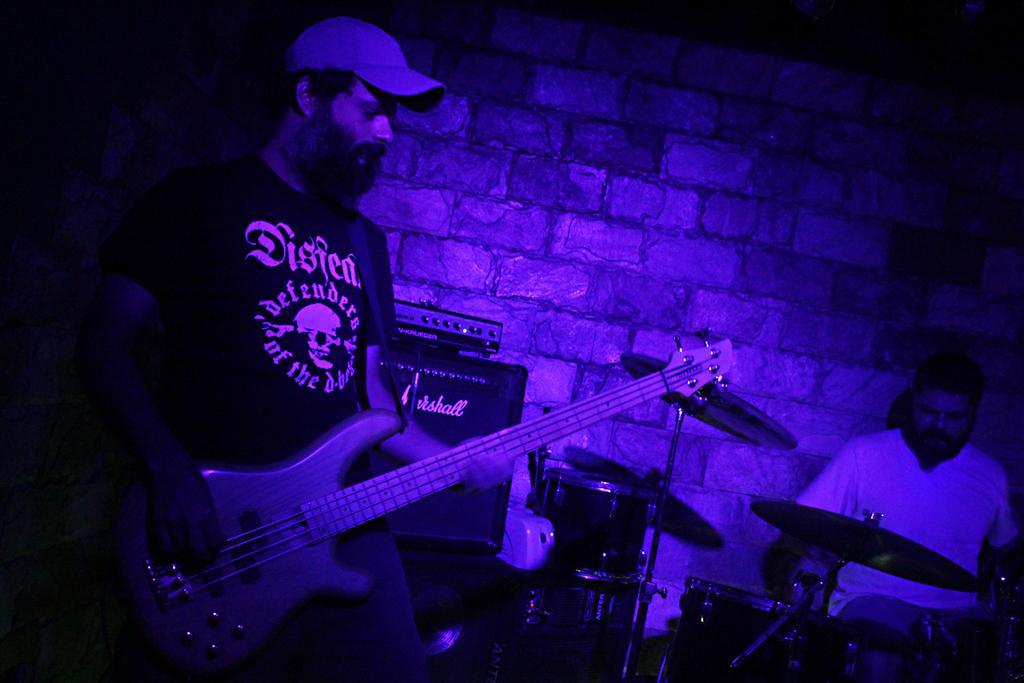Describe this image in one or two sentences. As we can see in the image there is a brick wall and two people over here and the man who is standing on the left side is playing guitar and the man on right side is playing musical drums. 